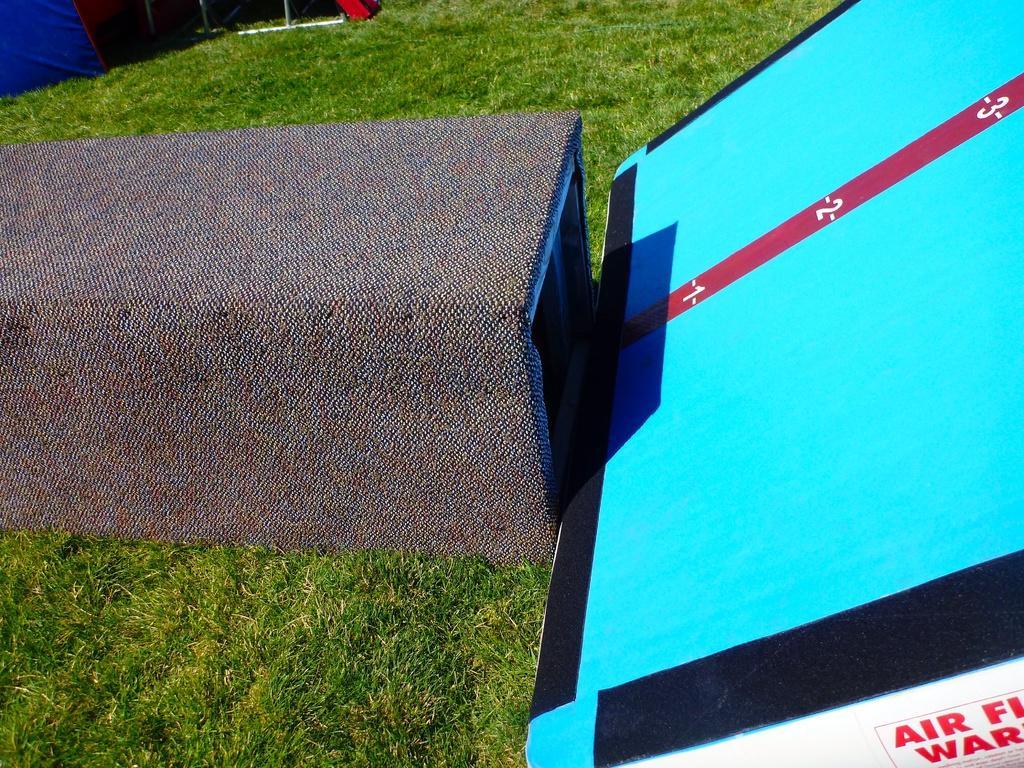Describe this image in one or two sentences. In this image I can see a blue,black and red color board. In front I can see a box and green grass. Numbers are on the board. Back Side I can see few objects. 